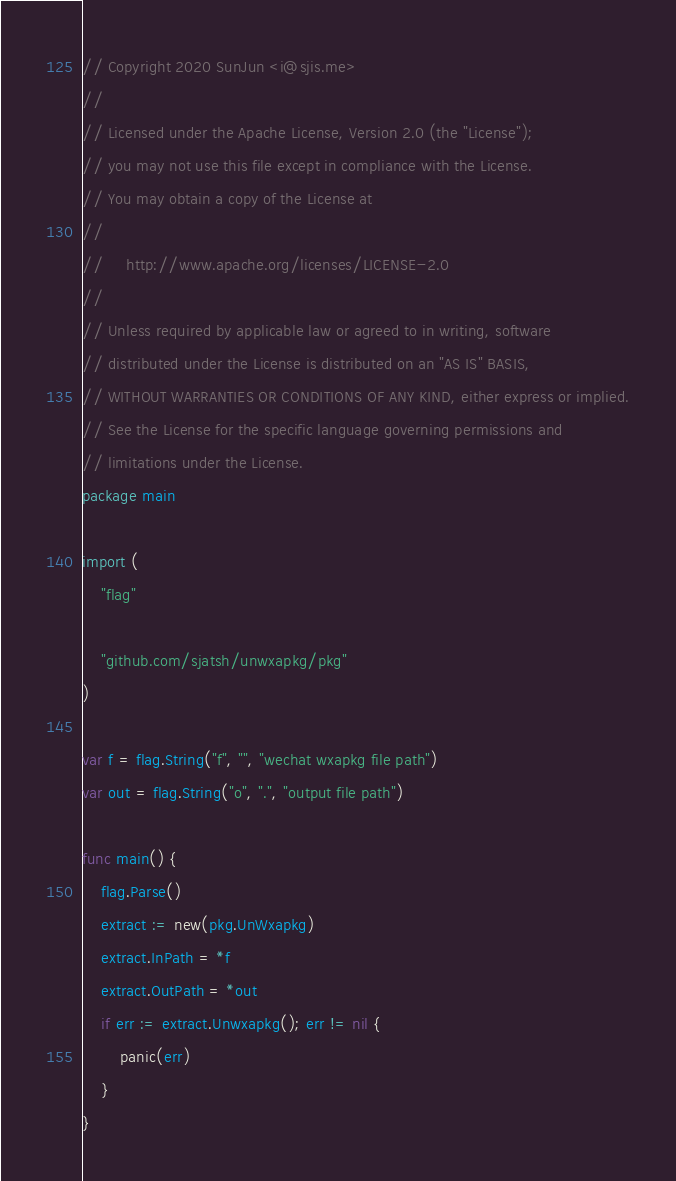<code> <loc_0><loc_0><loc_500><loc_500><_Go_>// Copyright 2020 SunJun <i@sjis.me>
//
// Licensed under the Apache License, Version 2.0 (the "License");
// you may not use this file except in compliance with the License.
// You may obtain a copy of the License at
//
//     http://www.apache.org/licenses/LICENSE-2.0
//
// Unless required by applicable law or agreed to in writing, software
// distributed under the License is distributed on an "AS IS" BASIS,
// WITHOUT WARRANTIES OR CONDITIONS OF ANY KIND, either express or implied.
// See the License for the specific language governing permissions and
// limitations under the License.
package main

import (
	"flag"

	"github.com/sjatsh/unwxapkg/pkg"
)

var f = flag.String("f", "", "wechat wxapkg file path")
var out = flag.String("o", ".", "output file path")

func main() {
	flag.Parse()
	extract := new(pkg.UnWxapkg)
	extract.InPath = *f
	extract.OutPath = *out
	if err := extract.Unwxapkg(); err != nil {
		panic(err)
	}
}
</code> 